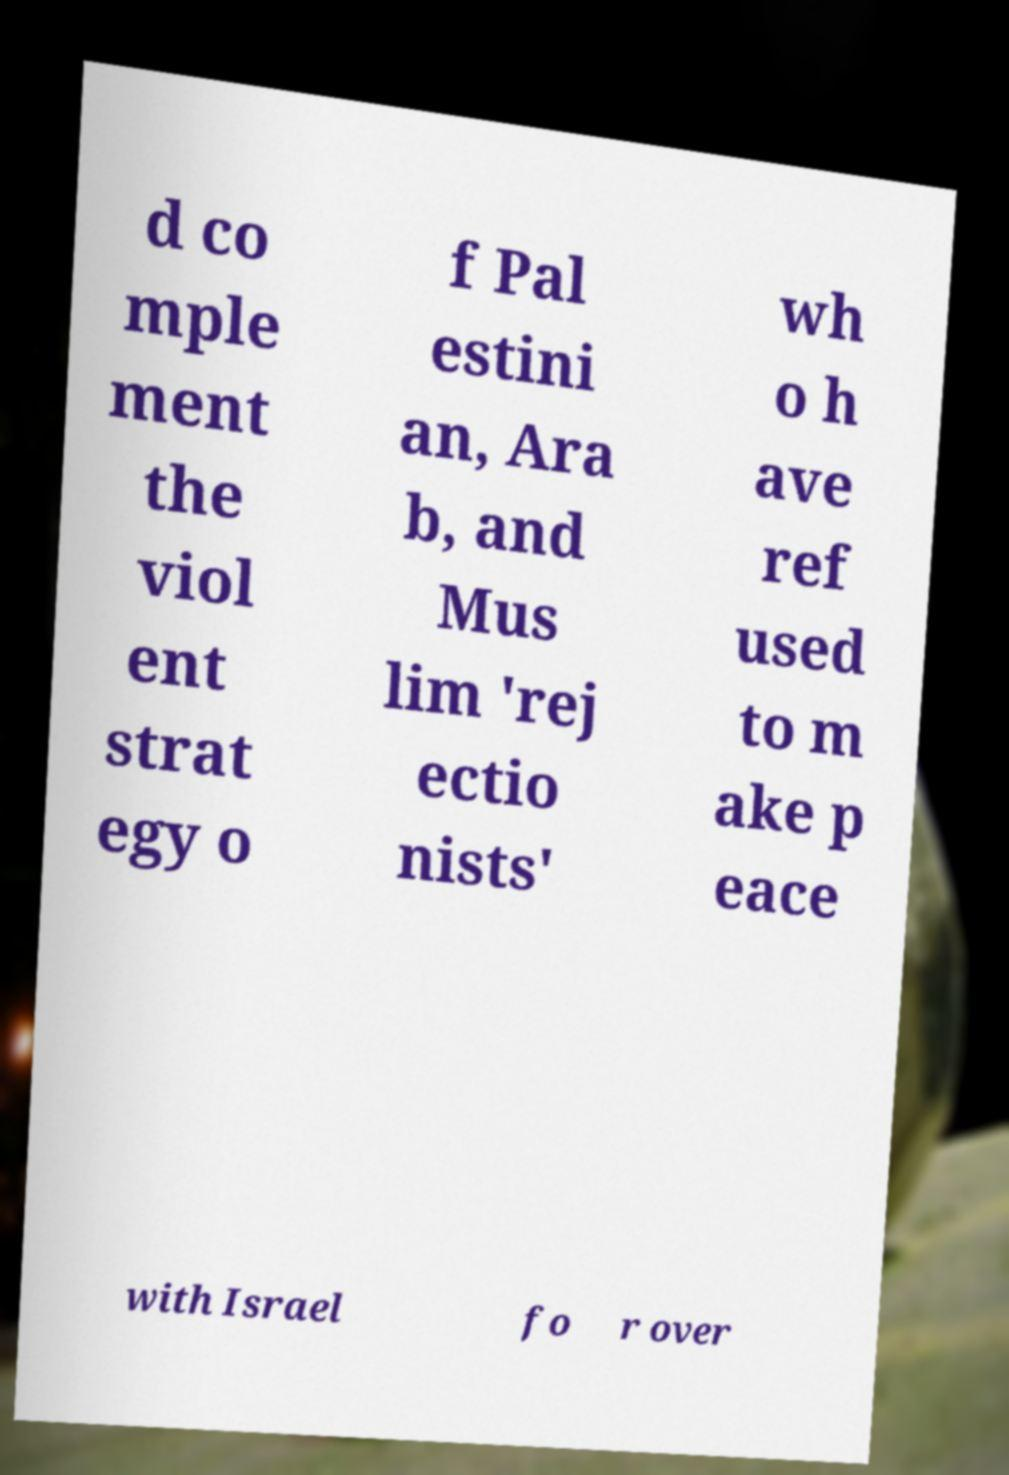Please read and relay the text visible in this image. What does it say? d co mple ment the viol ent strat egy o f Pal estini an, Ara b, and Mus lim 'rej ectio nists' wh o h ave ref used to m ake p eace with Israel fo r over 